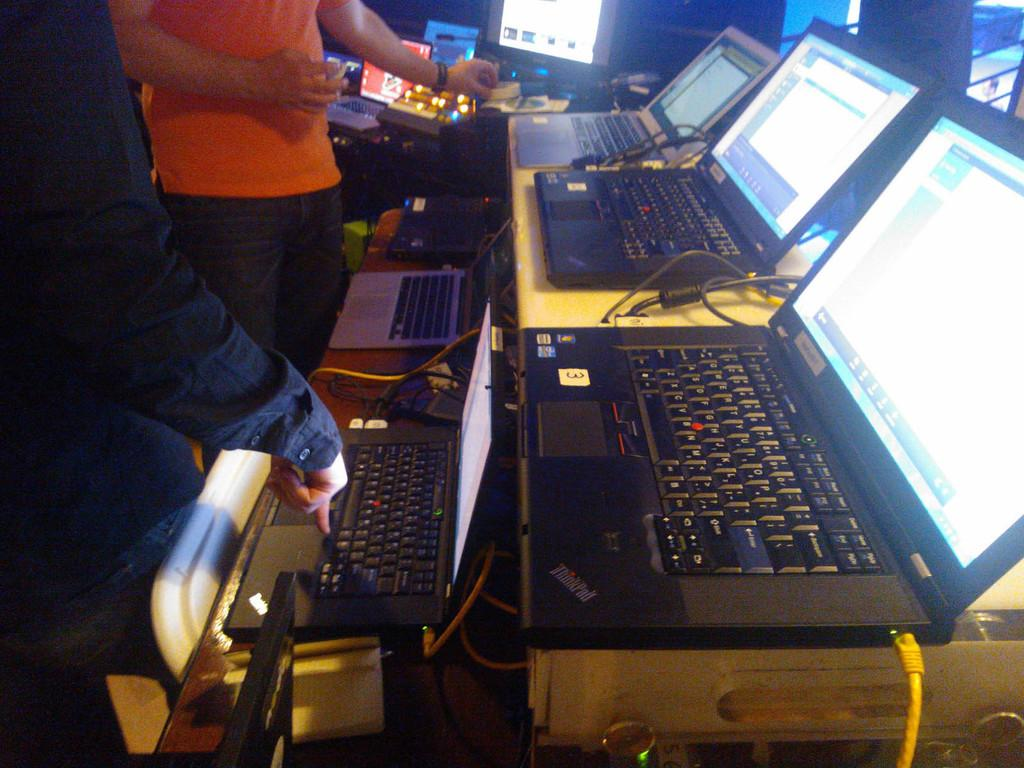<image>
Summarize the visual content of the image. A ThinkPad brand laptop sits among other laptops on a large desk. 